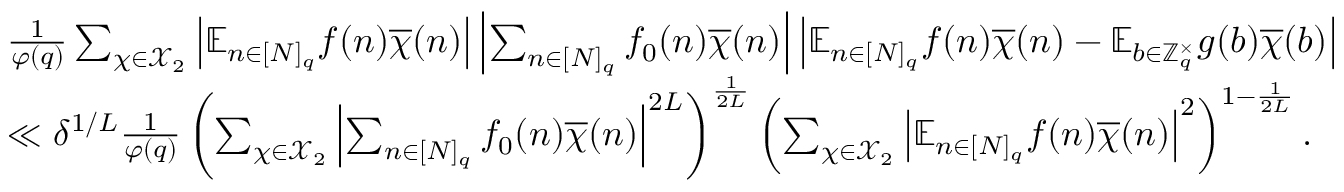<formula> <loc_0><loc_0><loc_500><loc_500>\begin{array} { r } { \begin{array} { r l } & { \frac { 1 } { \varphi ( q ) } \sum _ { \chi \in \mathcal { X } _ { 2 } } \left | \mathbb { E } _ { n \in [ N ] _ { q } } f ( n ) \overline { \chi } ( n ) \right | \left | \sum _ { n \in [ N ] _ { q } } f _ { 0 } ( n ) \overline { \chi } ( n ) \right | \left | \mathbb { E } _ { n \in [ N ] _ { q } } f ( n ) \overline { \chi } ( n ) - \mathbb { E } _ { b \in \mathbb { Z } _ { q } ^ { \times } } g ( b ) \overline { \chi } ( b ) \right | } \\ & { \ll \delta ^ { 1 / L } \frac { 1 } { \varphi ( q ) } \left ( \sum _ { \chi \in \mathcal { X } _ { 2 } } \left | \sum _ { n \in [ N ] _ { q } } f _ { 0 } ( n ) \overline { \chi } ( n ) \right | ^ { 2 L } \right ) ^ { \frac { 1 } { 2 L } } \left ( \sum _ { \chi \in \mathcal { X } _ { 2 } } \left | \mathbb { E } _ { n \in [ N ] _ { q } } f ( n ) \overline { \chi } ( n ) \right | ^ { 2 } \right ) ^ { 1 - \frac { 1 } { 2 L } } . } \end{array} } \end{array}</formula> 